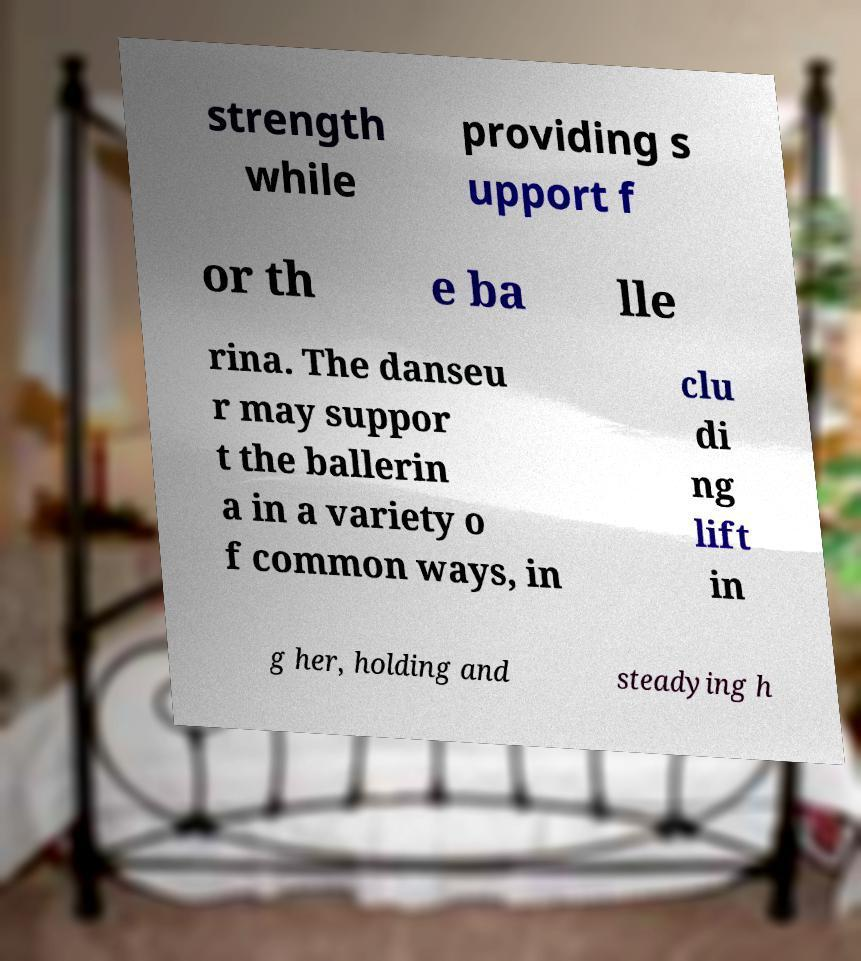There's text embedded in this image that I need extracted. Can you transcribe it verbatim? strength while providing s upport f or th e ba lle rina. The danseu r may suppor t the ballerin a in a variety o f common ways, in clu di ng lift in g her, holding and steadying h 